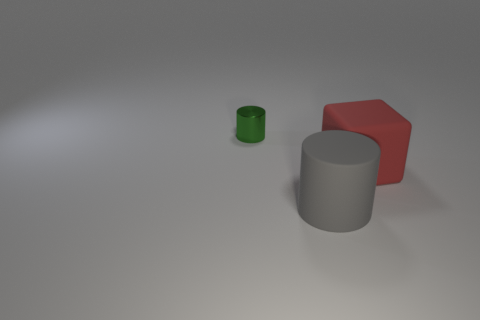Add 3 yellow metal cylinders. How many objects exist? 6 Subtract all cylinders. How many objects are left? 1 Subtract all red objects. Subtract all green objects. How many objects are left? 1 Add 1 large gray objects. How many large gray objects are left? 2 Add 3 shiny things. How many shiny things exist? 4 Subtract 0 green spheres. How many objects are left? 3 